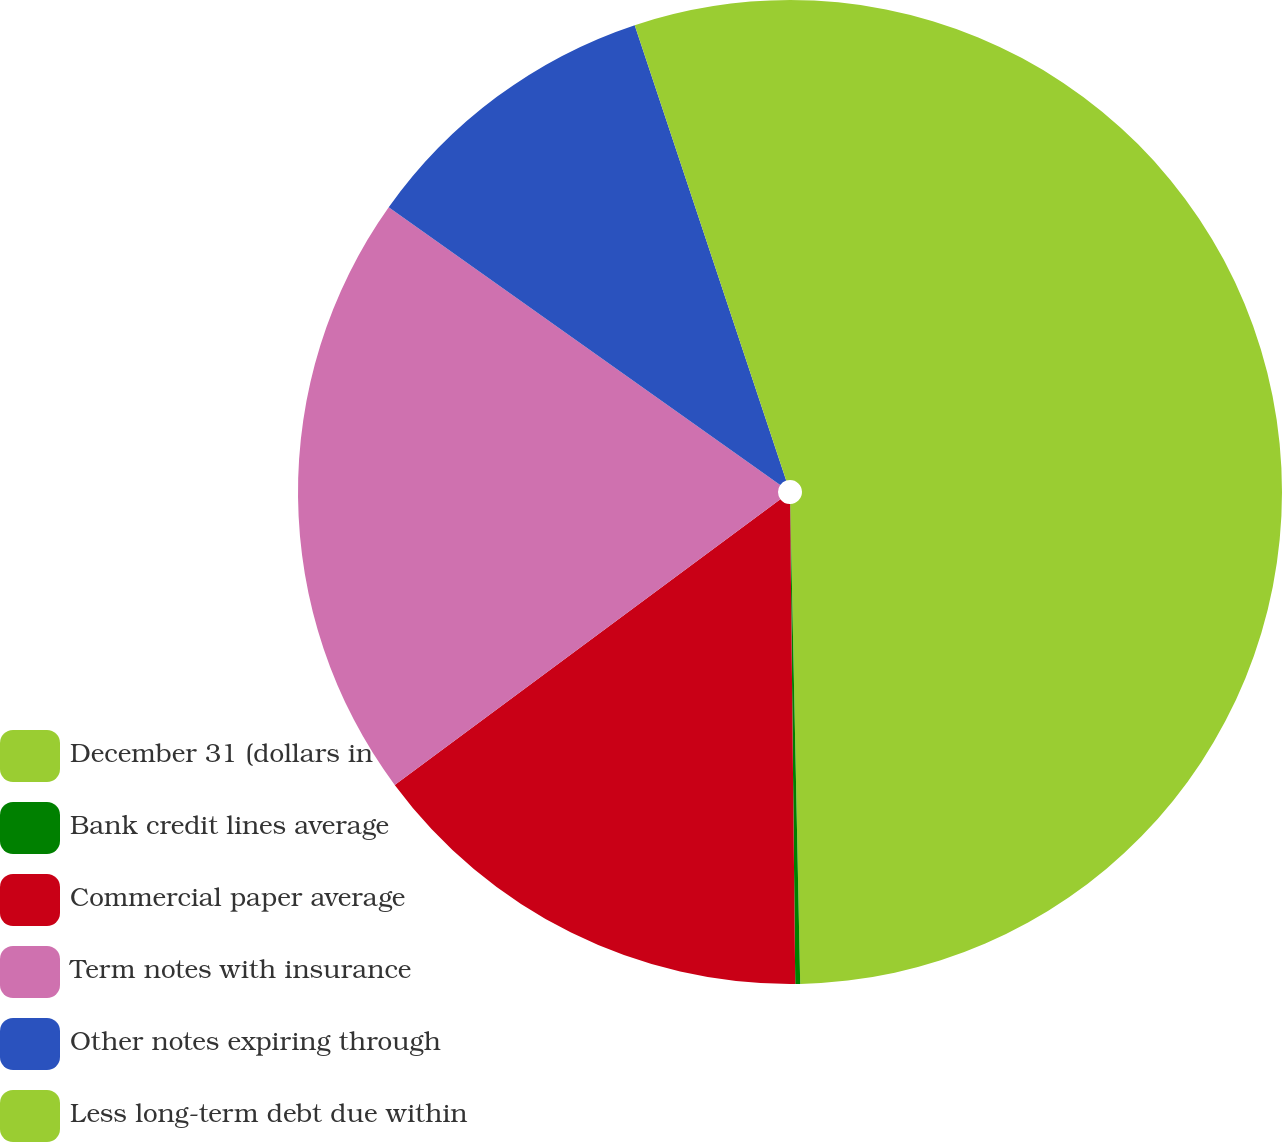Convert chart to OTSL. <chart><loc_0><loc_0><loc_500><loc_500><pie_chart><fcel>December 31 (dollars in<fcel>Bank credit lines average<fcel>Commercial paper average<fcel>Term notes with insurance<fcel>Other notes expiring through<fcel>Less long-term debt due within<nl><fcel>49.67%<fcel>0.16%<fcel>15.02%<fcel>19.97%<fcel>10.07%<fcel>5.11%<nl></chart> 